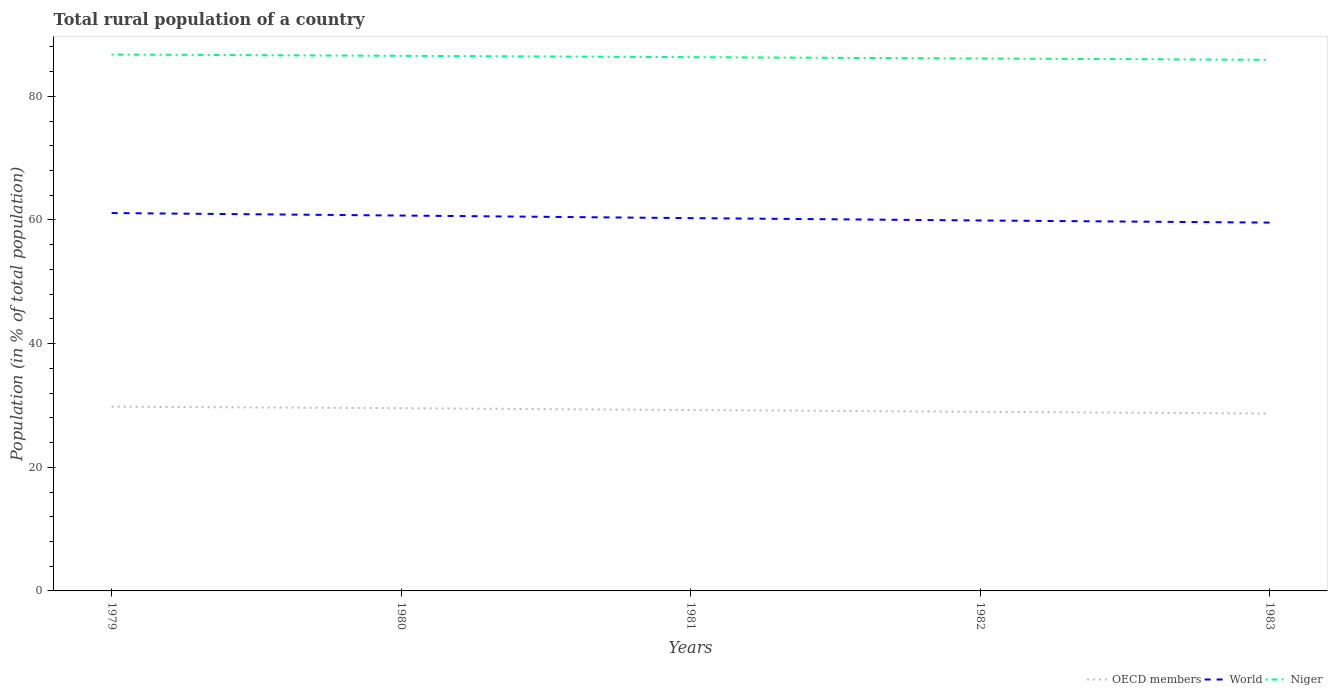How many different coloured lines are there?
Provide a short and direct response. 3. Is the number of lines equal to the number of legend labels?
Make the answer very short. Yes. Across all years, what is the maximum rural population in Niger?
Keep it short and to the point. 85.91. In which year was the rural population in World maximum?
Provide a short and direct response. 1983. What is the total rural population in Niger in the graph?
Make the answer very short. 0.64. What is the difference between the highest and the second highest rural population in Niger?
Keep it short and to the point. 0.86. What is the difference between the highest and the lowest rural population in Niger?
Keep it short and to the point. 3. How many lines are there?
Keep it short and to the point. 3. How many years are there in the graph?
Your answer should be very brief. 5. Are the values on the major ticks of Y-axis written in scientific E-notation?
Your response must be concise. No. Does the graph contain grids?
Provide a short and direct response. No. How are the legend labels stacked?
Offer a very short reply. Horizontal. What is the title of the graph?
Your response must be concise. Total rural population of a country. Does "High income" appear as one of the legend labels in the graph?
Offer a terse response. No. What is the label or title of the X-axis?
Give a very brief answer. Years. What is the label or title of the Y-axis?
Your response must be concise. Population (in % of total population). What is the Population (in % of total population) of OECD members in 1979?
Your response must be concise. 29.8. What is the Population (in % of total population) in World in 1979?
Keep it short and to the point. 61.12. What is the Population (in % of total population) in Niger in 1979?
Your answer should be compact. 86.77. What is the Population (in % of total population) of OECD members in 1980?
Your answer should be compact. 29.56. What is the Population (in % of total population) in World in 1980?
Your answer should be compact. 60.72. What is the Population (in % of total population) in Niger in 1980?
Give a very brief answer. 86.56. What is the Population (in % of total population) of OECD members in 1981?
Provide a short and direct response. 29.26. What is the Population (in % of total population) in World in 1981?
Offer a terse response. 60.3. What is the Population (in % of total population) in Niger in 1981?
Offer a very short reply. 86.34. What is the Population (in % of total population) of OECD members in 1982?
Provide a short and direct response. 28.97. What is the Population (in % of total population) in World in 1982?
Provide a short and direct response. 59.92. What is the Population (in % of total population) of Niger in 1982?
Offer a very short reply. 86.13. What is the Population (in % of total population) in OECD members in 1983?
Your answer should be very brief. 28.7. What is the Population (in % of total population) in World in 1983?
Your answer should be compact. 59.58. What is the Population (in % of total population) of Niger in 1983?
Ensure brevity in your answer.  85.91. Across all years, what is the maximum Population (in % of total population) of OECD members?
Your response must be concise. 29.8. Across all years, what is the maximum Population (in % of total population) in World?
Offer a terse response. 61.12. Across all years, what is the maximum Population (in % of total population) in Niger?
Keep it short and to the point. 86.77. Across all years, what is the minimum Population (in % of total population) of OECD members?
Offer a terse response. 28.7. Across all years, what is the minimum Population (in % of total population) in World?
Keep it short and to the point. 59.58. Across all years, what is the minimum Population (in % of total population) of Niger?
Keep it short and to the point. 85.91. What is the total Population (in % of total population) of OECD members in the graph?
Your answer should be very brief. 146.29. What is the total Population (in % of total population) in World in the graph?
Ensure brevity in your answer.  301.65. What is the total Population (in % of total population) in Niger in the graph?
Provide a succinct answer. 431.71. What is the difference between the Population (in % of total population) of OECD members in 1979 and that in 1980?
Your response must be concise. 0.24. What is the difference between the Population (in % of total population) in World in 1979 and that in 1980?
Keep it short and to the point. 0.4. What is the difference between the Population (in % of total population) in Niger in 1979 and that in 1980?
Offer a very short reply. 0.21. What is the difference between the Population (in % of total population) in OECD members in 1979 and that in 1981?
Ensure brevity in your answer.  0.54. What is the difference between the Population (in % of total population) of World in 1979 and that in 1981?
Offer a very short reply. 0.82. What is the difference between the Population (in % of total population) of Niger in 1979 and that in 1981?
Provide a short and direct response. 0.42. What is the difference between the Population (in % of total population) in OECD members in 1979 and that in 1982?
Your response must be concise. 0.83. What is the difference between the Population (in % of total population) in World in 1979 and that in 1982?
Ensure brevity in your answer.  1.2. What is the difference between the Population (in % of total population) in Niger in 1979 and that in 1982?
Provide a short and direct response. 0.64. What is the difference between the Population (in % of total population) in OECD members in 1979 and that in 1983?
Your answer should be very brief. 1.1. What is the difference between the Population (in % of total population) of World in 1979 and that in 1983?
Keep it short and to the point. 1.54. What is the difference between the Population (in % of total population) in Niger in 1979 and that in 1983?
Provide a succinct answer. 0.86. What is the difference between the Population (in % of total population) of OECD members in 1980 and that in 1981?
Your answer should be very brief. 0.3. What is the difference between the Population (in % of total population) of World in 1980 and that in 1981?
Provide a short and direct response. 0.42. What is the difference between the Population (in % of total population) of Niger in 1980 and that in 1981?
Your response must be concise. 0.21. What is the difference between the Population (in % of total population) in OECD members in 1980 and that in 1982?
Make the answer very short. 0.59. What is the difference between the Population (in % of total population) in World in 1980 and that in 1982?
Ensure brevity in your answer.  0.8. What is the difference between the Population (in % of total population) of Niger in 1980 and that in 1982?
Offer a terse response. 0.43. What is the difference between the Population (in % of total population) of OECD members in 1980 and that in 1983?
Provide a succinct answer. 0.86. What is the difference between the Population (in % of total population) of World in 1980 and that in 1983?
Ensure brevity in your answer.  1.14. What is the difference between the Population (in % of total population) of Niger in 1980 and that in 1983?
Your response must be concise. 0.65. What is the difference between the Population (in % of total population) of OECD members in 1981 and that in 1982?
Your answer should be very brief. 0.29. What is the difference between the Population (in % of total population) in World in 1981 and that in 1982?
Your answer should be compact. 0.38. What is the difference between the Population (in % of total population) in Niger in 1981 and that in 1982?
Ensure brevity in your answer.  0.21. What is the difference between the Population (in % of total population) of OECD members in 1981 and that in 1983?
Your answer should be very brief. 0.56. What is the difference between the Population (in % of total population) in World in 1981 and that in 1983?
Offer a very short reply. 0.72. What is the difference between the Population (in % of total population) of Niger in 1981 and that in 1983?
Your answer should be very brief. 0.43. What is the difference between the Population (in % of total population) in OECD members in 1982 and that in 1983?
Offer a very short reply. 0.27. What is the difference between the Population (in % of total population) of World in 1982 and that in 1983?
Make the answer very short. 0.34. What is the difference between the Population (in % of total population) of Niger in 1982 and that in 1983?
Provide a short and direct response. 0.22. What is the difference between the Population (in % of total population) in OECD members in 1979 and the Population (in % of total population) in World in 1980?
Give a very brief answer. -30.92. What is the difference between the Population (in % of total population) in OECD members in 1979 and the Population (in % of total population) in Niger in 1980?
Offer a terse response. -56.76. What is the difference between the Population (in % of total population) in World in 1979 and the Population (in % of total population) in Niger in 1980?
Your answer should be compact. -25.43. What is the difference between the Population (in % of total population) of OECD members in 1979 and the Population (in % of total population) of World in 1981?
Offer a terse response. -30.5. What is the difference between the Population (in % of total population) of OECD members in 1979 and the Population (in % of total population) of Niger in 1981?
Keep it short and to the point. -56.54. What is the difference between the Population (in % of total population) in World in 1979 and the Population (in % of total population) in Niger in 1981?
Give a very brief answer. -25.22. What is the difference between the Population (in % of total population) of OECD members in 1979 and the Population (in % of total population) of World in 1982?
Provide a succinct answer. -30.12. What is the difference between the Population (in % of total population) of OECD members in 1979 and the Population (in % of total population) of Niger in 1982?
Your response must be concise. -56.33. What is the difference between the Population (in % of total population) of World in 1979 and the Population (in % of total population) of Niger in 1982?
Offer a very short reply. -25.01. What is the difference between the Population (in % of total population) in OECD members in 1979 and the Population (in % of total population) in World in 1983?
Ensure brevity in your answer.  -29.78. What is the difference between the Population (in % of total population) of OECD members in 1979 and the Population (in % of total population) of Niger in 1983?
Ensure brevity in your answer.  -56.11. What is the difference between the Population (in % of total population) in World in 1979 and the Population (in % of total population) in Niger in 1983?
Offer a very short reply. -24.79. What is the difference between the Population (in % of total population) of OECD members in 1980 and the Population (in % of total population) of World in 1981?
Ensure brevity in your answer.  -30.74. What is the difference between the Population (in % of total population) in OECD members in 1980 and the Population (in % of total population) in Niger in 1981?
Offer a very short reply. -56.79. What is the difference between the Population (in % of total population) in World in 1980 and the Population (in % of total population) in Niger in 1981?
Ensure brevity in your answer.  -25.62. What is the difference between the Population (in % of total population) of OECD members in 1980 and the Population (in % of total population) of World in 1982?
Provide a succinct answer. -30.37. What is the difference between the Population (in % of total population) in OECD members in 1980 and the Population (in % of total population) in Niger in 1982?
Keep it short and to the point. -56.57. What is the difference between the Population (in % of total population) in World in 1980 and the Population (in % of total population) in Niger in 1982?
Provide a short and direct response. -25.41. What is the difference between the Population (in % of total population) of OECD members in 1980 and the Population (in % of total population) of World in 1983?
Your answer should be compact. -30.02. What is the difference between the Population (in % of total population) of OECD members in 1980 and the Population (in % of total population) of Niger in 1983?
Your answer should be very brief. -56.35. What is the difference between the Population (in % of total population) in World in 1980 and the Population (in % of total population) in Niger in 1983?
Keep it short and to the point. -25.19. What is the difference between the Population (in % of total population) of OECD members in 1981 and the Population (in % of total population) of World in 1982?
Your answer should be compact. -30.66. What is the difference between the Population (in % of total population) of OECD members in 1981 and the Population (in % of total population) of Niger in 1982?
Provide a succinct answer. -56.87. What is the difference between the Population (in % of total population) in World in 1981 and the Population (in % of total population) in Niger in 1982?
Keep it short and to the point. -25.83. What is the difference between the Population (in % of total population) in OECD members in 1981 and the Population (in % of total population) in World in 1983?
Ensure brevity in your answer.  -30.32. What is the difference between the Population (in % of total population) in OECD members in 1981 and the Population (in % of total population) in Niger in 1983?
Provide a short and direct response. -56.65. What is the difference between the Population (in % of total population) in World in 1981 and the Population (in % of total population) in Niger in 1983?
Provide a succinct answer. -25.61. What is the difference between the Population (in % of total population) of OECD members in 1982 and the Population (in % of total population) of World in 1983?
Your answer should be very brief. -30.61. What is the difference between the Population (in % of total population) in OECD members in 1982 and the Population (in % of total population) in Niger in 1983?
Ensure brevity in your answer.  -56.94. What is the difference between the Population (in % of total population) of World in 1982 and the Population (in % of total population) of Niger in 1983?
Keep it short and to the point. -25.99. What is the average Population (in % of total population) in OECD members per year?
Make the answer very short. 29.26. What is the average Population (in % of total population) in World per year?
Offer a terse response. 60.33. What is the average Population (in % of total population) in Niger per year?
Keep it short and to the point. 86.34. In the year 1979, what is the difference between the Population (in % of total population) of OECD members and Population (in % of total population) of World?
Provide a short and direct response. -31.32. In the year 1979, what is the difference between the Population (in % of total population) in OECD members and Population (in % of total population) in Niger?
Keep it short and to the point. -56.97. In the year 1979, what is the difference between the Population (in % of total population) in World and Population (in % of total population) in Niger?
Ensure brevity in your answer.  -25.64. In the year 1980, what is the difference between the Population (in % of total population) of OECD members and Population (in % of total population) of World?
Offer a very short reply. -31.16. In the year 1980, what is the difference between the Population (in % of total population) in OECD members and Population (in % of total population) in Niger?
Make the answer very short. -57. In the year 1980, what is the difference between the Population (in % of total population) in World and Population (in % of total population) in Niger?
Make the answer very short. -25.84. In the year 1981, what is the difference between the Population (in % of total population) in OECD members and Population (in % of total population) in World?
Offer a terse response. -31.04. In the year 1981, what is the difference between the Population (in % of total population) in OECD members and Population (in % of total population) in Niger?
Make the answer very short. -57.08. In the year 1981, what is the difference between the Population (in % of total population) of World and Population (in % of total population) of Niger?
Offer a very short reply. -26.04. In the year 1982, what is the difference between the Population (in % of total population) of OECD members and Population (in % of total population) of World?
Make the answer very short. -30.95. In the year 1982, what is the difference between the Population (in % of total population) in OECD members and Population (in % of total population) in Niger?
Make the answer very short. -57.16. In the year 1982, what is the difference between the Population (in % of total population) in World and Population (in % of total population) in Niger?
Offer a very short reply. -26.21. In the year 1983, what is the difference between the Population (in % of total population) of OECD members and Population (in % of total population) of World?
Keep it short and to the point. -30.88. In the year 1983, what is the difference between the Population (in % of total population) of OECD members and Population (in % of total population) of Niger?
Keep it short and to the point. -57.21. In the year 1983, what is the difference between the Population (in % of total population) in World and Population (in % of total population) in Niger?
Offer a terse response. -26.33. What is the ratio of the Population (in % of total population) in OECD members in 1979 to that in 1980?
Ensure brevity in your answer.  1.01. What is the ratio of the Population (in % of total population) in World in 1979 to that in 1980?
Provide a succinct answer. 1.01. What is the ratio of the Population (in % of total population) of Niger in 1979 to that in 1980?
Your response must be concise. 1. What is the ratio of the Population (in % of total population) in OECD members in 1979 to that in 1981?
Your answer should be compact. 1.02. What is the ratio of the Population (in % of total population) of World in 1979 to that in 1981?
Your answer should be compact. 1.01. What is the ratio of the Population (in % of total population) in OECD members in 1979 to that in 1982?
Your answer should be very brief. 1.03. What is the ratio of the Population (in % of total population) of World in 1979 to that in 1982?
Your answer should be compact. 1.02. What is the ratio of the Population (in % of total population) of Niger in 1979 to that in 1982?
Give a very brief answer. 1.01. What is the ratio of the Population (in % of total population) in OECD members in 1979 to that in 1983?
Provide a succinct answer. 1.04. What is the ratio of the Population (in % of total population) in World in 1979 to that in 1983?
Offer a terse response. 1.03. What is the ratio of the Population (in % of total population) in Niger in 1979 to that in 1983?
Make the answer very short. 1.01. What is the ratio of the Population (in % of total population) of OECD members in 1980 to that in 1981?
Your answer should be compact. 1.01. What is the ratio of the Population (in % of total population) in World in 1980 to that in 1981?
Provide a short and direct response. 1.01. What is the ratio of the Population (in % of total population) in OECD members in 1980 to that in 1982?
Provide a succinct answer. 1.02. What is the ratio of the Population (in % of total population) of World in 1980 to that in 1982?
Offer a very short reply. 1.01. What is the ratio of the Population (in % of total population) of Niger in 1980 to that in 1982?
Give a very brief answer. 1. What is the ratio of the Population (in % of total population) in World in 1980 to that in 1983?
Offer a very short reply. 1.02. What is the ratio of the Population (in % of total population) of Niger in 1980 to that in 1983?
Provide a short and direct response. 1.01. What is the ratio of the Population (in % of total population) of OECD members in 1981 to that in 1983?
Offer a terse response. 1.02. What is the ratio of the Population (in % of total population) in World in 1981 to that in 1983?
Provide a short and direct response. 1.01. What is the ratio of the Population (in % of total population) in Niger in 1981 to that in 1983?
Your answer should be very brief. 1.01. What is the ratio of the Population (in % of total population) of OECD members in 1982 to that in 1983?
Your response must be concise. 1.01. What is the ratio of the Population (in % of total population) in World in 1982 to that in 1983?
Offer a very short reply. 1.01. What is the ratio of the Population (in % of total population) of Niger in 1982 to that in 1983?
Your response must be concise. 1. What is the difference between the highest and the second highest Population (in % of total population) of OECD members?
Provide a short and direct response. 0.24. What is the difference between the highest and the second highest Population (in % of total population) of World?
Keep it short and to the point. 0.4. What is the difference between the highest and the second highest Population (in % of total population) in Niger?
Your response must be concise. 0.21. What is the difference between the highest and the lowest Population (in % of total population) of OECD members?
Offer a very short reply. 1.1. What is the difference between the highest and the lowest Population (in % of total population) in World?
Keep it short and to the point. 1.54. What is the difference between the highest and the lowest Population (in % of total population) of Niger?
Your response must be concise. 0.86. 